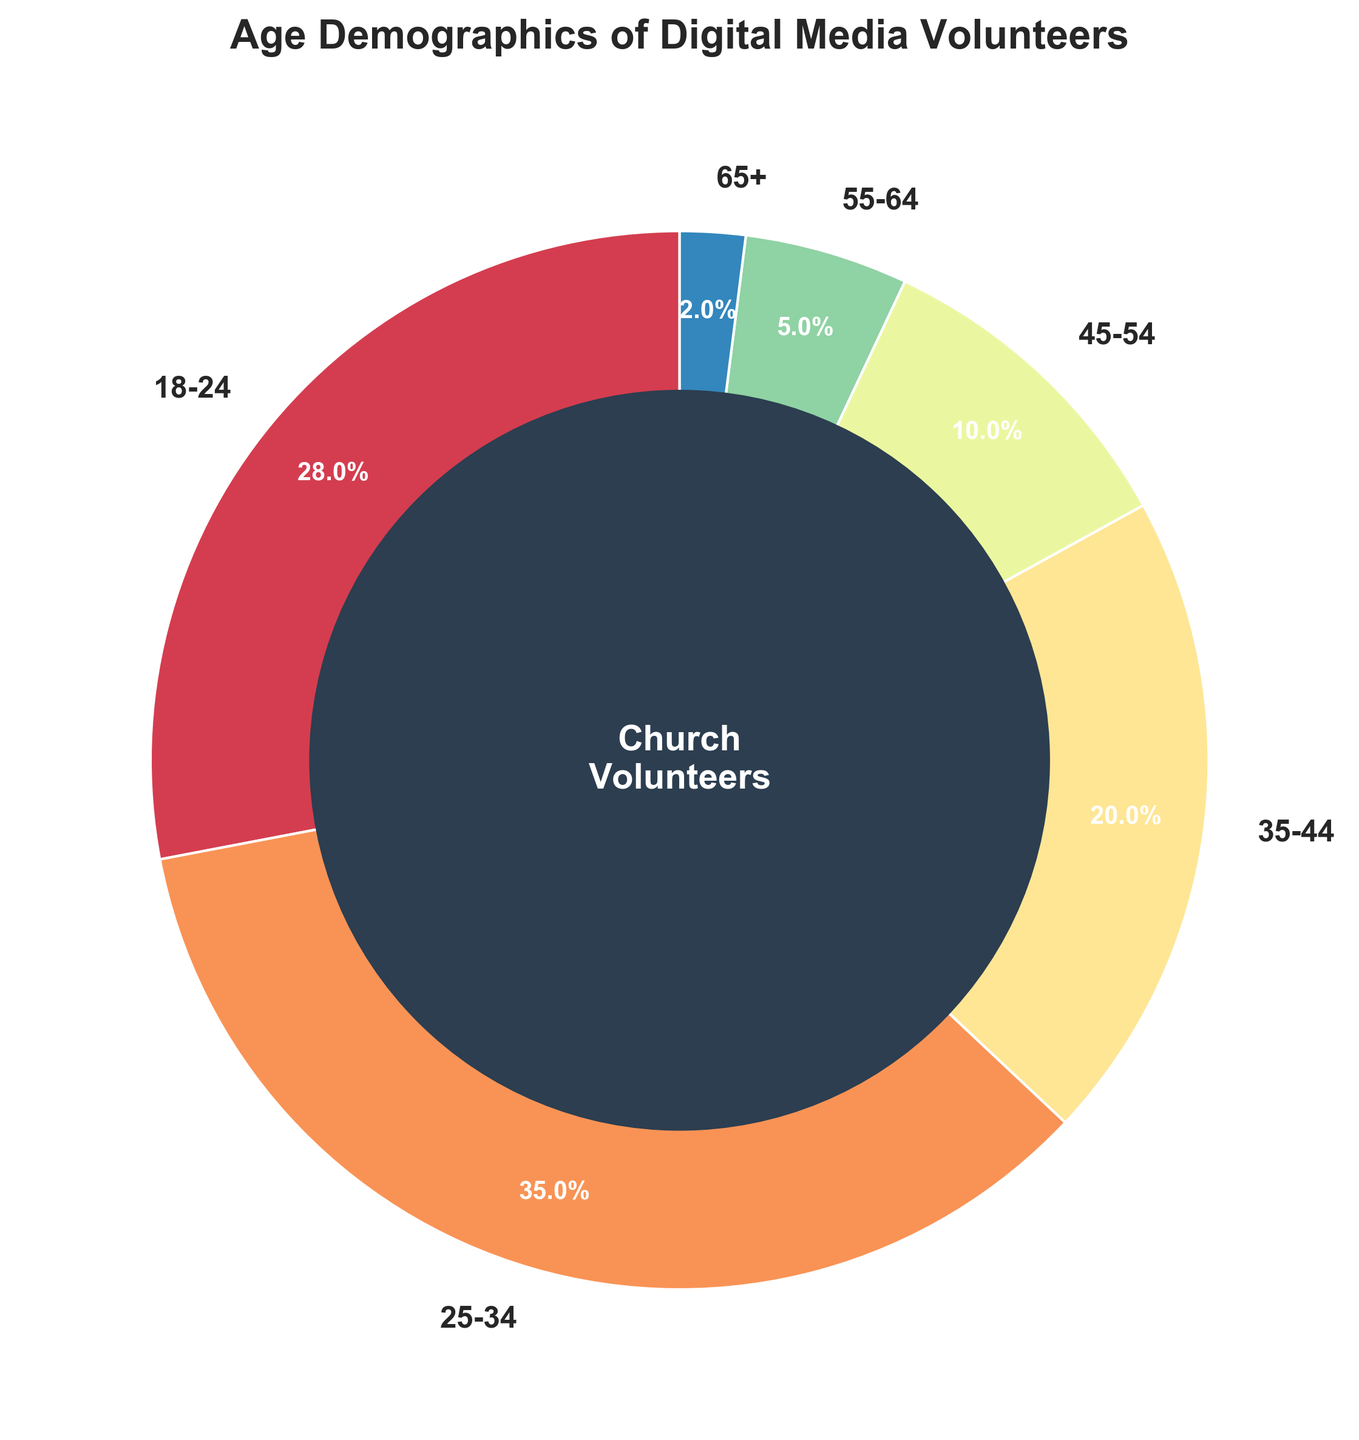What percentage of volunteers are aged 18-24? The chart shows the age group 18-24 with a corresponding percentage.
Answer: 28% How does the percentage of volunteers aged 25-34 compare to those aged 35-44? From the chart, the age group 25-34 has a percentage of 35, while the age group 35-44 has a percentage of 20. Thus, the 25-34 group has a higher percentage.
Answer: 25-34 has a higher percentage Which age group has the least representation among the volunteers? The smallest wedge in the pie chart is for the age group 65+, indicating the least representation.
Answer: 65+ What is the combined percentage of volunteers aged 55 and older? To get the combined percentage, add the percentages for the 55-64 group (5%) and the 65+ group (2%). 5 + 2 = 7
Answer: 7% What visual element is used to highlight the center of the pie chart? The chart’s center has a dark blue circle with the text "Church Volunteers" in white.
Answer: Dark blue circle with text How much larger is the percentage of volunteers aged 18-24 compared to those aged 45-54? The percentage for 18-24 is 28%, and for 45-54 is 10%. Subtract 10 from 28 to find the difference, 28 - 10 = 18.
Answer: 18% What is the title of the chart? The text at the top-center of the chart reads "Age Demographics of Digital Media Volunteers."
Answer: Age Demographics of Digital Media Volunteers Which two age groups combined make up more than half of the volunteers? The age groups 18-24 (28%) and 25-34 (35%) together make up 28 + 35 = 63%, which is more than half.
Answer: 18-24 and 25-34 Which color scheme is used for the pie chart? The colors used in the pie chart range from light to dark in a gradient style, typical of the Spectral color map.
Answer: Gradient (Spectral) 